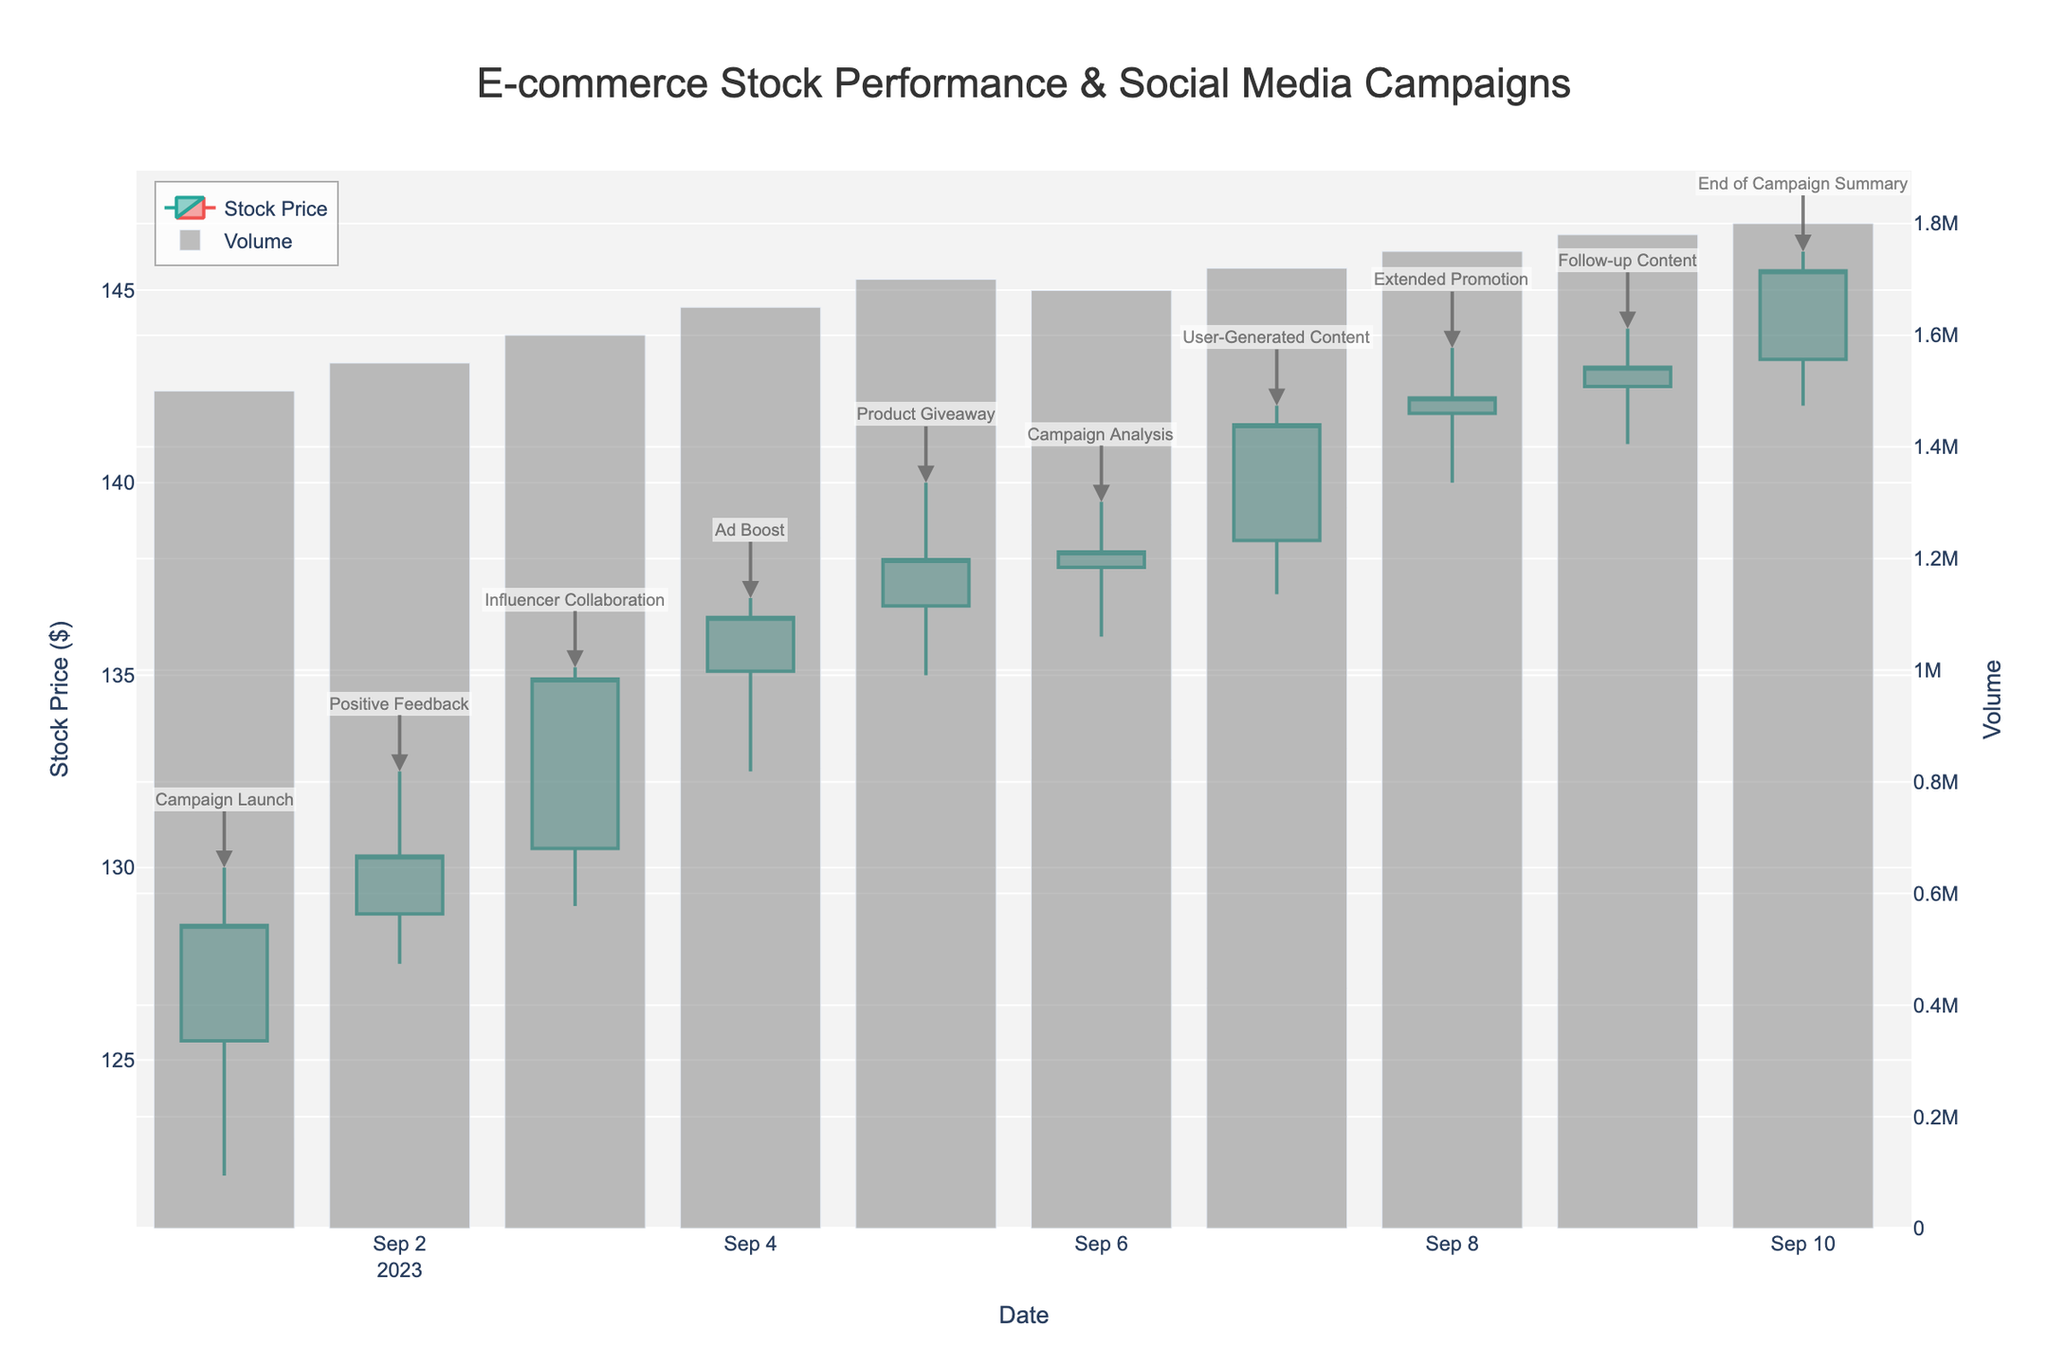When did the "Campaign Launch" happen? The "Campaign Launch" is annotated on the first candlestick, which corresponds to the date labeled at the start of the x-axis.
Answer: 2023-09-01 What was the highest stock price during the "Influencer Collaboration"? The "Influencer Collaboration" annotation is on the third candlestick. From the plot, this candlestick's high price reaches 135.20.
Answer: 135.20 Compare the stock closing prices before and after the "Ad Boost". Was there an increase or decrease? The "Ad Boost" annotation appears on the fourth candlestick. The closing price before is on the third candlestick (134.90) and after is on the fourth candlestick (136.50). Subtract the former from the latter to see the change.
Answer: Increase What was the volume on the day of the "User-Generated Content"? The "User-Generated Content" annotation is on the seventh candlestick. The volume bar corresponding to this candlestick reaches up to, indicating 1720000.
Answer: 1720000 How much did the stock price rise from the "Campaign Launch" to the "Extended Promotion"? The "Campaign Launch" and "Extended Promotion" annotations are on the first and eighth candlesticks respectively. The closing price on the first day is 128.50 and on the eighth day is 142.20. Subtract the first from the second to get the rise.
Answer: 13.70 What day marks the highest closing price during the campaign? The closing prices are represented by the top of the candlestick's "body." The highest among them is visible at the top of the leading edge near the end of the figure (145.50). This corresponds to the last day, as annotated with "End of Campaign Summary".
Answer: 2023-09-10 Which campaign seemed to coincide with the highest trading volume? The bar height for the volume indicates the trading volume. The highest bar corresponds to the "End of Campaign Summary" annotation on the tenth candlestick.
Answer: End of Campaign Summary On which date did the stock price have the largest range (difference between high and low)? The range can be visually determined by the length of the candlestick wicks. The longest vertical line extends from the high to the low price on the candlestick for 2023-09-03 (Influencer Collaboration, 6.20).
Answer: 2023-09-03 Did all the annotated campaign days show a positive impact on stock prices? By examining the positive (green) and negative (red) candlesticks for each annotated campaign, we find that all days except "Ad Boost" have green candlesticks. "Ad Boost" has a slight increase but with a longer lower shadow suggesting intra-day volatility.
Answer: No How does the closing price on the final day compare to the beginning of the campaign? The closing price can be compared from the first candlestick (128.50) to the last candlestick (145.50). The difference indicates an increase.
Answer: Increased 